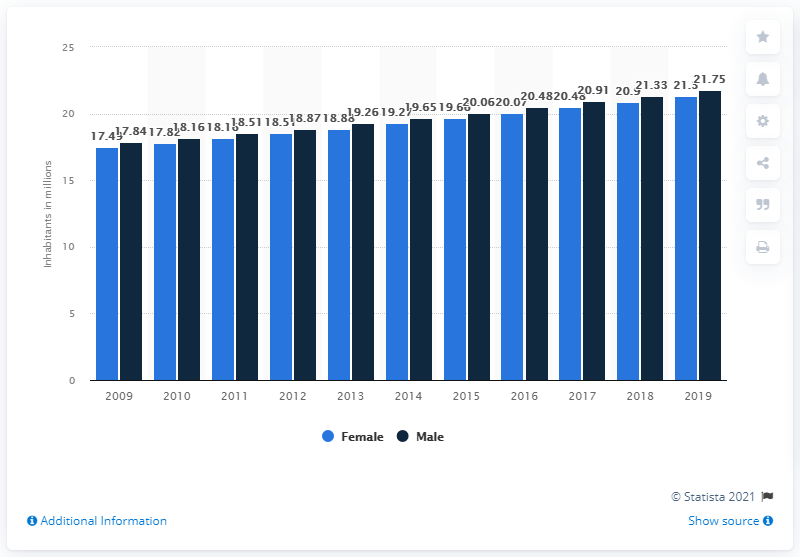Mention a couple of crucial points in this snapshot. According to estimates, in 2019, Algeria's female population was 21.3 million. The male population of Algeria in 2019 was 21.75 million. 